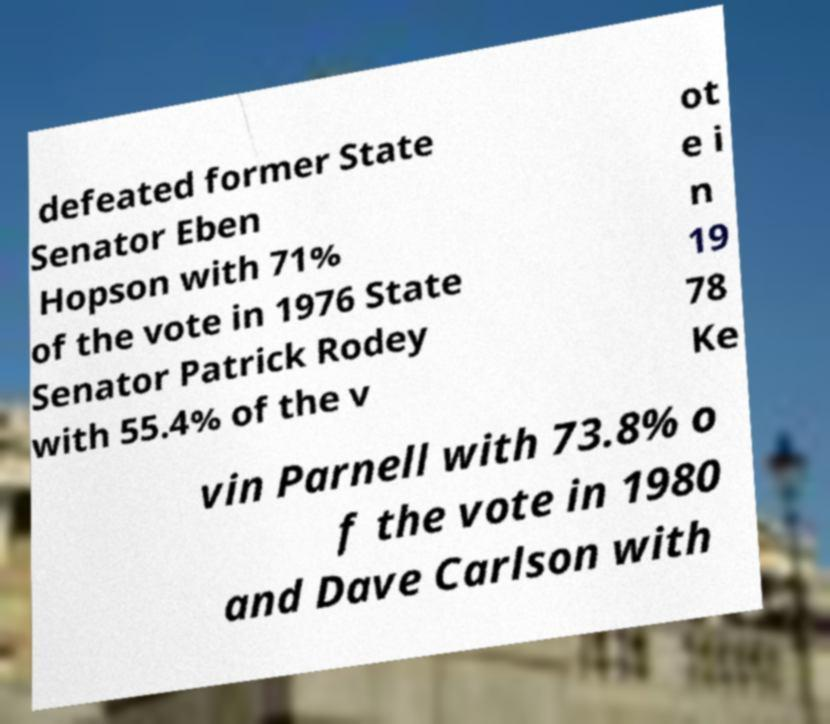There's text embedded in this image that I need extracted. Can you transcribe it verbatim? defeated former State Senator Eben Hopson with 71% of the vote in 1976 State Senator Patrick Rodey with 55.4% of the v ot e i n 19 78 Ke vin Parnell with 73.8% o f the vote in 1980 and Dave Carlson with 